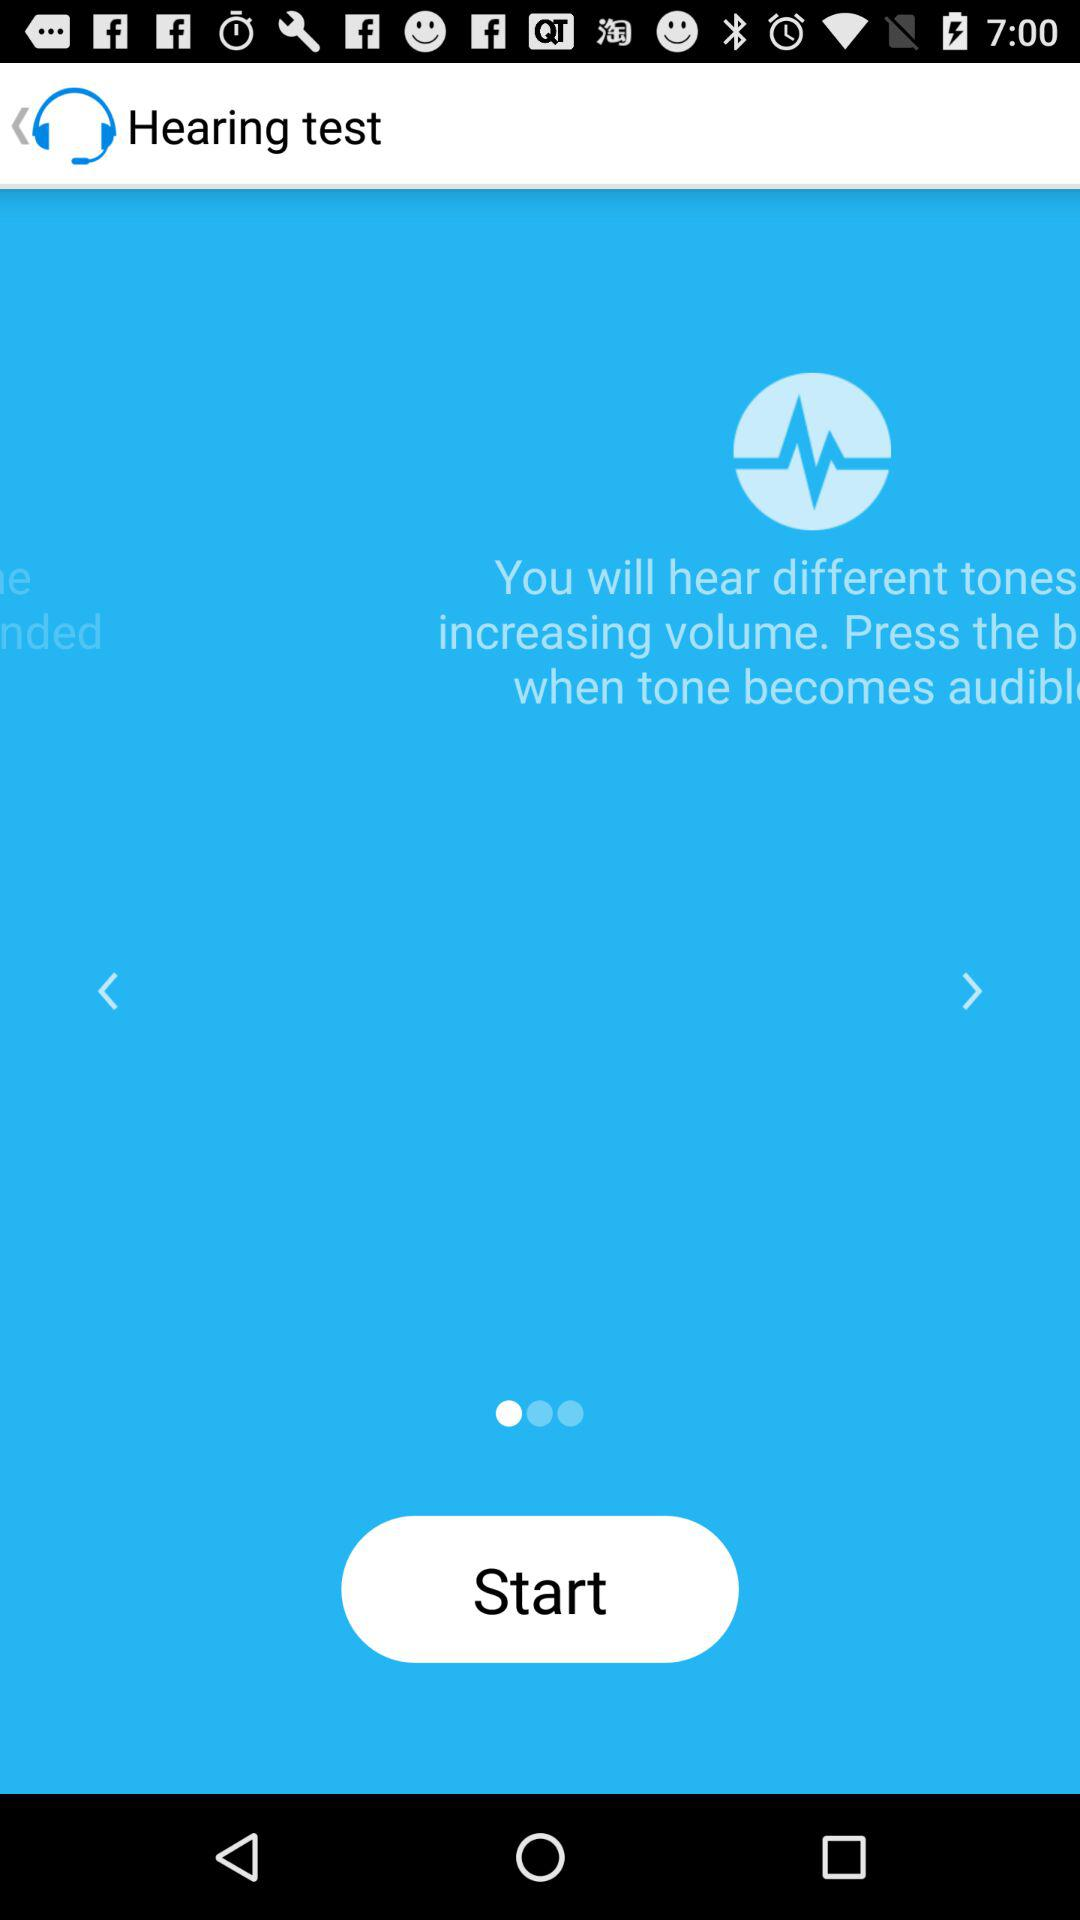What is the application name? The application name is "Hearing test". 